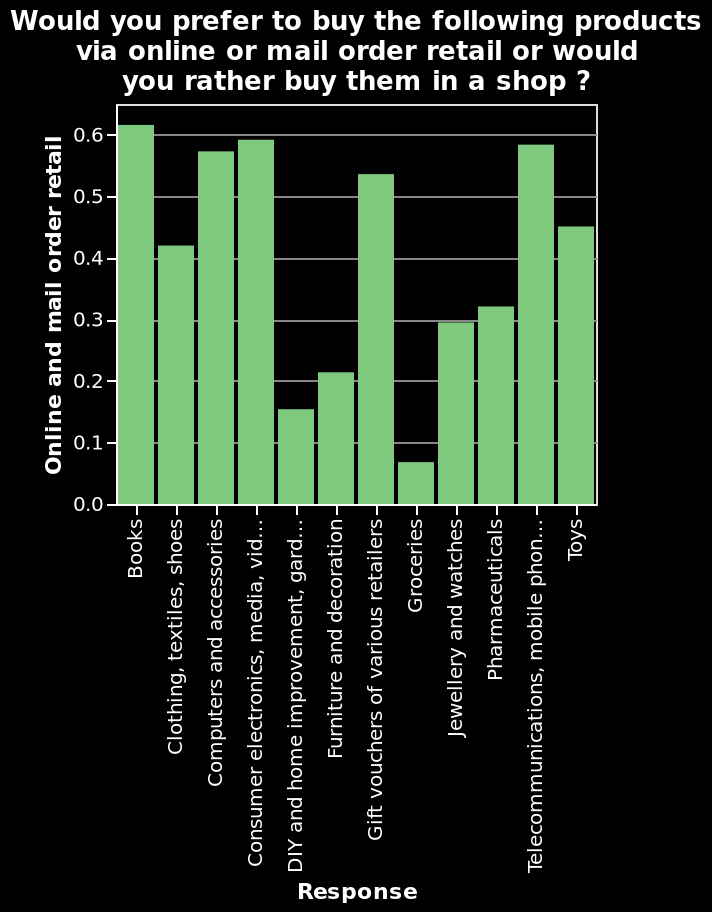<image>
How are the buying preferences represented in the bar diagram? The bar diagram represents the buying preferences by showing the heights of the bars for each category, indicating the level of preference for buying the products either online/mail order retail or in a shop. Does the bar diagram represent the buying preferences by showing the widths of the bars for each category, indicating the level of preference for buying the products either online/mail order retail or in a shop? No.The bar diagram represents the buying preferences by showing the heights of the bars for each category, indicating the level of preference for buying the products either online/mail order retail or in a shop. 